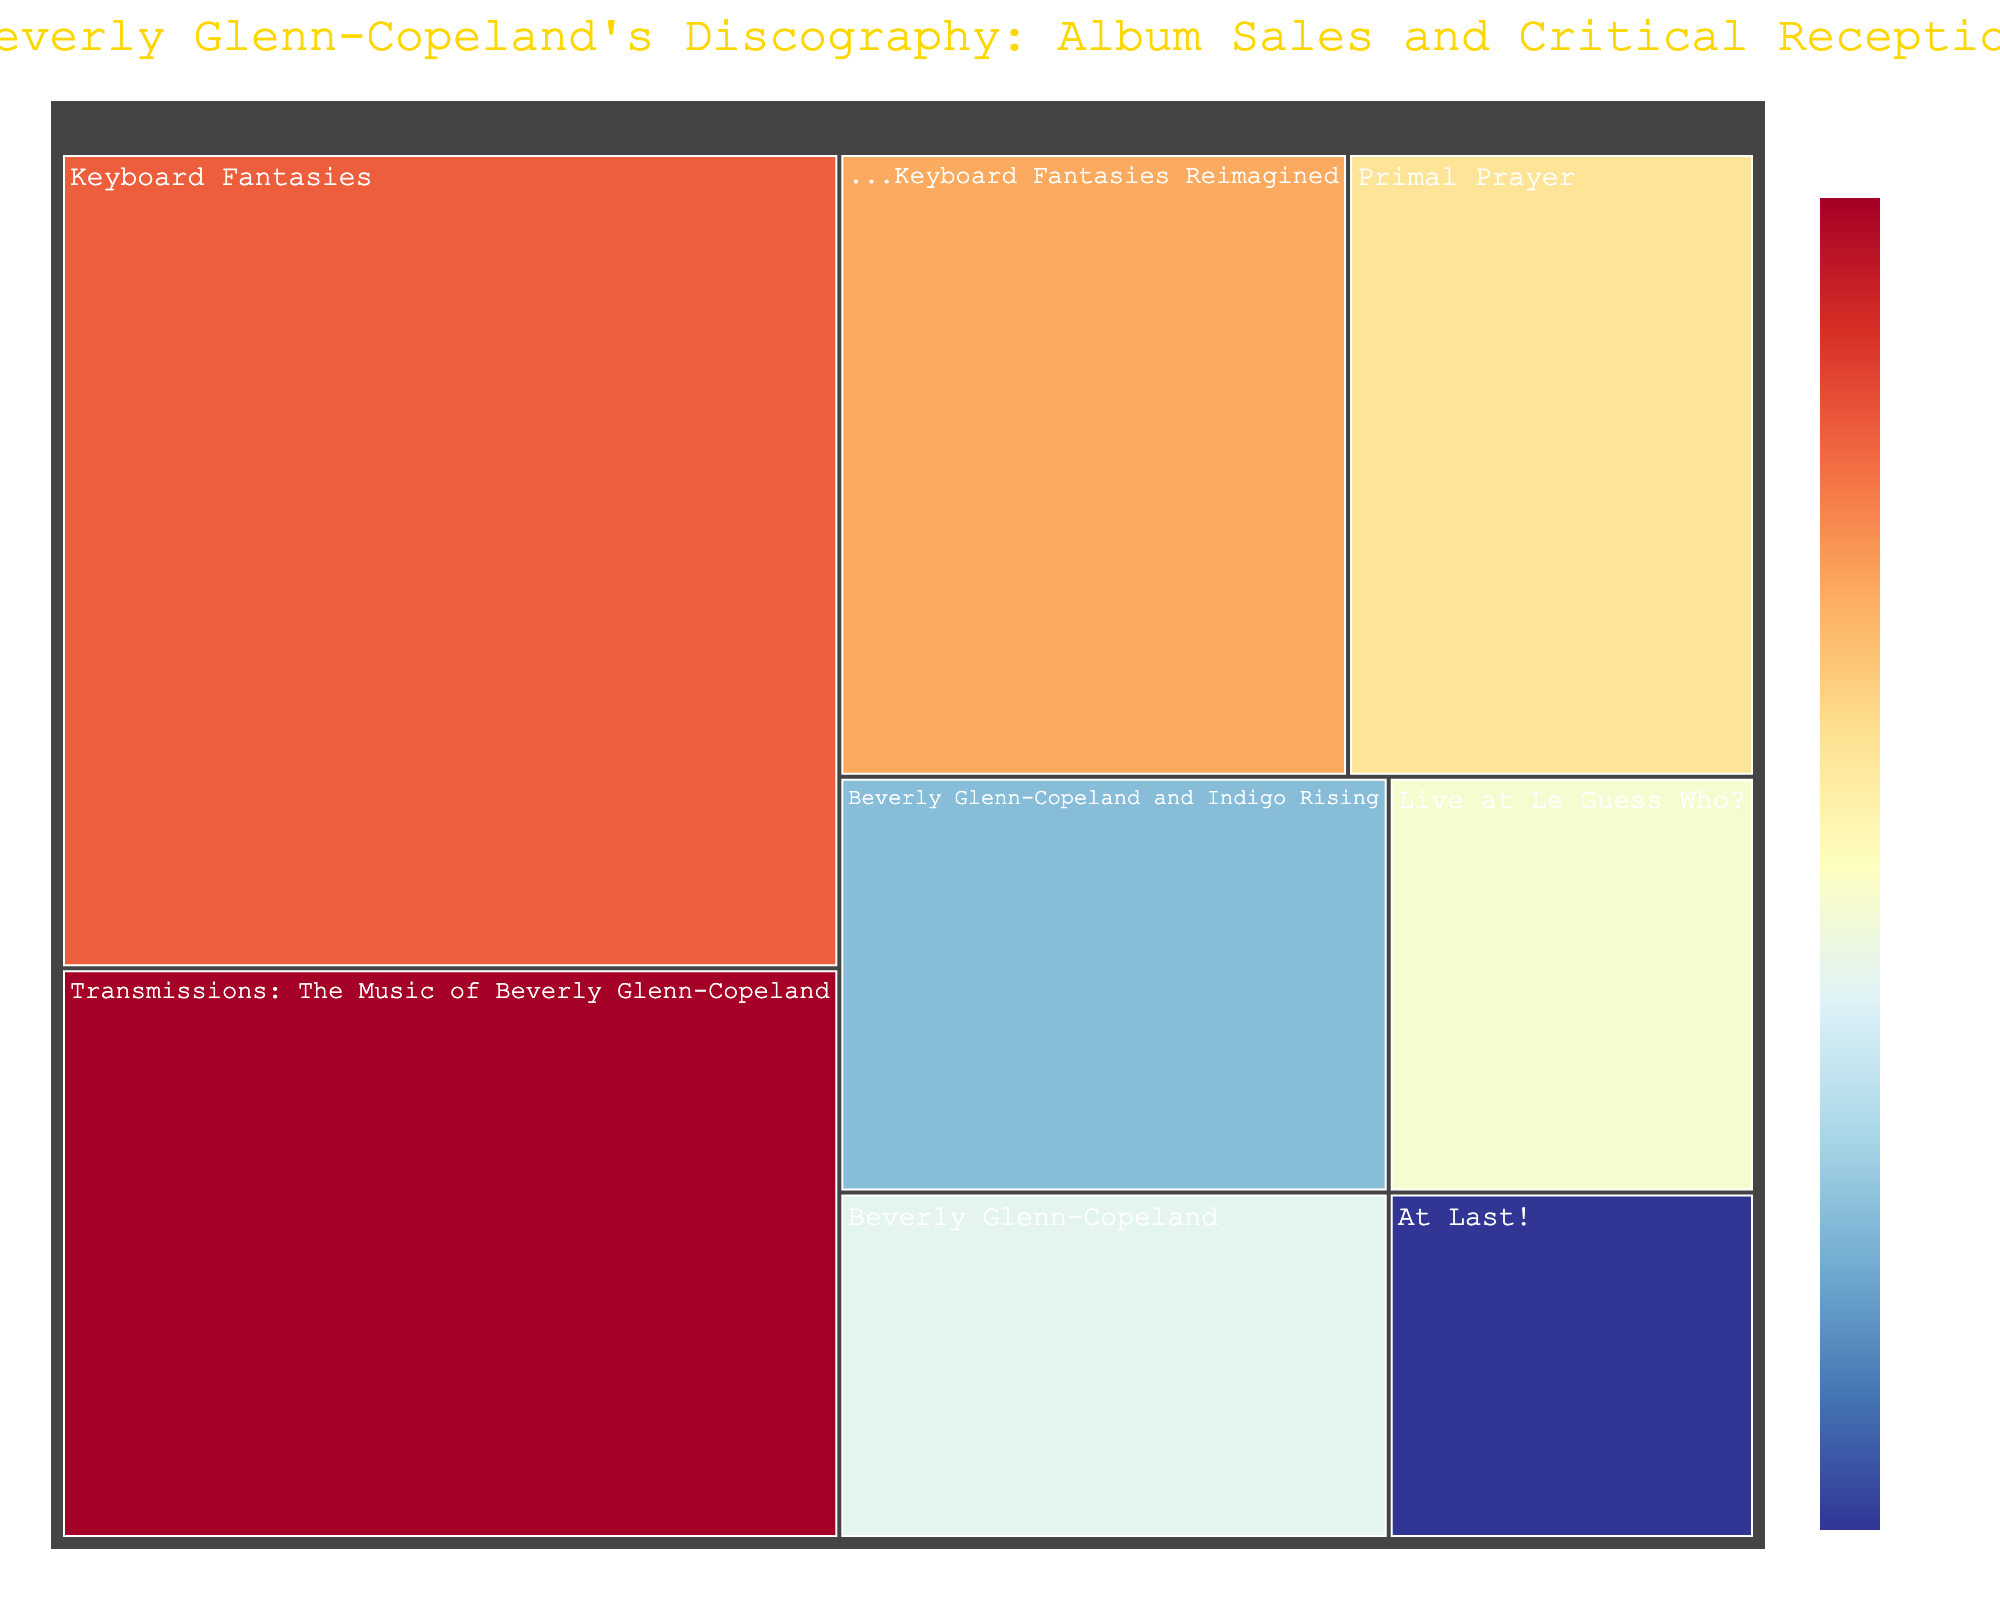What's the title of the figure? The title is displayed at the top-center of the Treemap, which indicates the main focus of the visualization.
Answer: Beverly Glenn-Copeland's Discography: Album Sales and Critical Reception Which album has the highest critical score? You need to look for the album with the highest value in the color legend. "Transmissions: The Music of Beverly Glenn-Copeland" has the highest critical score.
Answer: Transmissions: The Music of Beverly Glenn-Copeland How many albums have sales of 20,000? Identify the albums with sales figures equal to 20,000 in the 'Sales' field. Only "Primal Prayer" meets this criterion.
Answer: 1 What is the total sales figure for all albums? Sum the sales figures of all the albums: 50000 + 15000 + 10000 + 20000 + 35000 + 25000 + 18000 + 12000. The total is 185000.
Answer: 185000 Which album has the lowest critical score? Examine the 'CriticalScore' field and identify the lowest value. "At Last!" has the lowest critical score.
Answer: At Last! What is the average critical score of all albums? Average is obtained by summing all the critical scores and then dividing by the count of albums. Sum: 92 + 85 + 78 + 88 + 95 + 90 + 82 + 86 = 696. Count of albums: 8. Average: 696 / 8 = 87.
Answer: 87 Which album has slightly more sales, "Keyboard Fantasies Reimagined" or "Beverly Glenn-Copeland and Indigo Rising"? Compare the sales figures of the two albums. "Keyboard Fantasies Reimagined" has 25000, and "Beverly Glenn-Copeland and Indigo Rising" has 18000. 25000 is slightly higher.
Answer: Keyboard Fantasies Reimagined How does "Live at Le Guess Who?" compare in terms of sales and critical score? Look at the sales and critical score of "Live at Le Guess Who?". It has sales of 12000 and a critical score of 86.
Answer: 12000 sales, 86 critical score What color scheme does the Treemap use for the critical scores? The color scheme is based on the diverging RdYlBu colormap reversed, spanning from red to blue per the critical score range.
Answer: RdYlBu reversed Which album was considered highly critically successful but had relatively low sales? By cross-referencing high critical scores and low sales figures, "Beverly Glenn-Copeland" has a critical score of 85 but only 15000 in sales.
Answer: Beverly Glenn-Copeland 